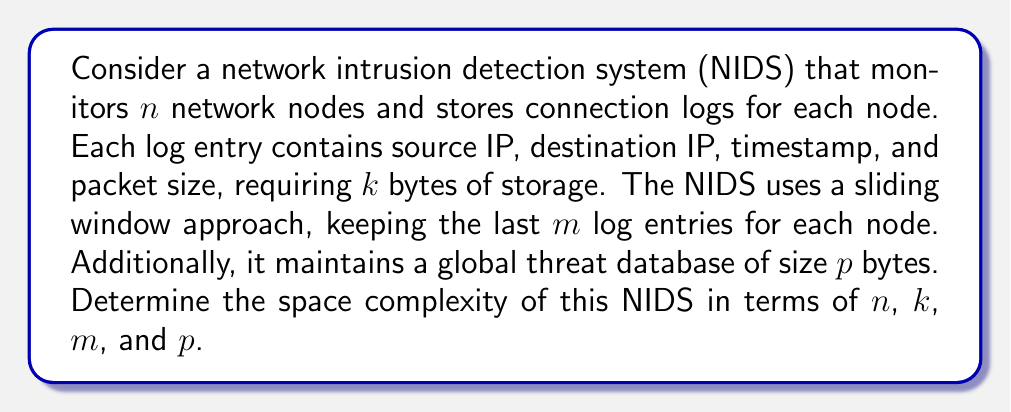Help me with this question. To determine the space complexity of the network intrusion detection system, we need to analyze the storage requirements for each component:

1. Connection logs:
   - Each node stores $m$ log entries
   - Each log entry requires $k$ bytes
   - There are $n$ nodes
   - Total space for logs: $n \times m \times k$ bytes

2. Global threat database:
   - Fixed size of $p$ bytes

3. Additional overhead:
   - We can assume a constant overhead $c$ for the NIDS software itself

The total space required is the sum of these components:

$$S(n, k, m, p) = (n \times m \times k) + p + c$$

Since $c$ is a constant, we can omit it in the big-O notation. Therefore, the space complexity is:

$$O(nmk + p)$$

This complexity analysis shows that the space requirements grow linearly with the number of nodes ($n$), the number of log entries per node ($m$), and the size of each log entry ($k$). The global threat database size ($p$) is added as a constant term.

For a cyber warfare expert, it's crucial to understand this complexity as it directly impacts the scalability and resource requirements of the NIDS. In a competitive scenario, optimizing these parameters could provide a significant advantage in deploying more efficient intrusion detection systems across larger networks.
Answer: The space complexity of the network intrusion detection system is $O(nmk + p)$, where $n$ is the number of network nodes, $m$ is the number of log entries per node, $k$ is the size of each log entry, and $p$ is the size of the global threat database. 